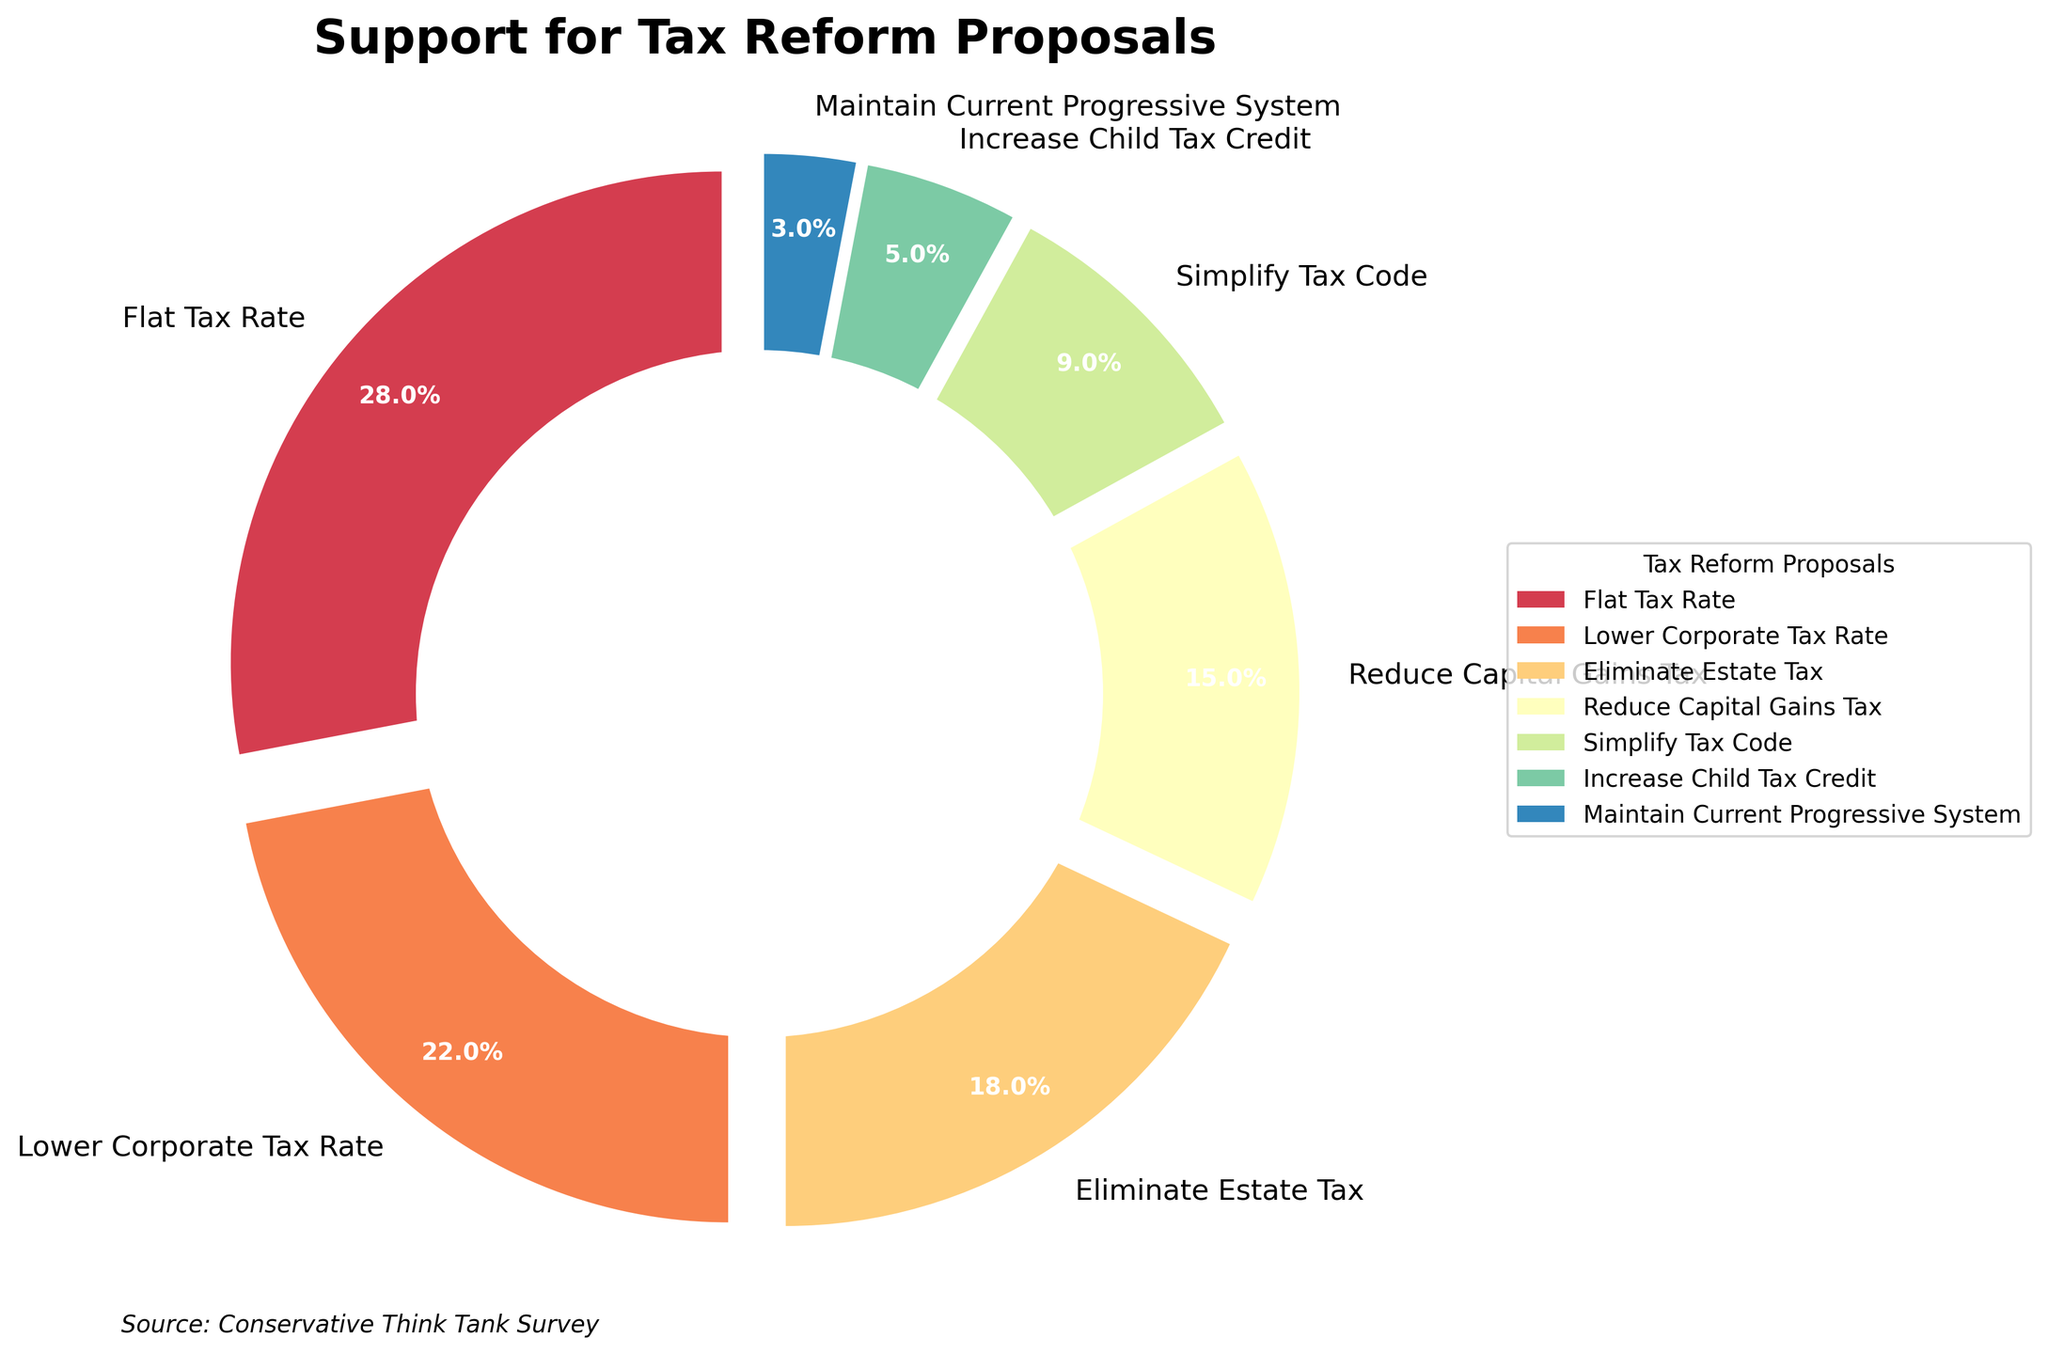What percentage of Americans support the Flat Tax Rate proposal? The Flat Tax Rate segment shows 28% support on the pie chart.
Answer: 28% Which tax reform proposal has the least support? The pie chart indicates that the Current Progressive System has the least support with 3%.
Answer: Current Progressive System By how much does the support for Lower Corporate Tax Rate exceed the support for Reduce Capital Gains Tax? The support for Lower Corporate Tax Rate is 22%, and for Reduce Capital Gains Tax it is 15%. The difference is 22% - 15%.
Answer: 7% What is the combined percentage of Americans supporting the "Eliminate Estate Tax" and "Simplify Tax Code" proposals? The support for Eliminate Estate Tax is 18% and for Simplify Tax Code is 9%. Adding these gives 18% + 9%.
Answer: 27% Which two proposals together account for the largest share of support and what is their combined percentage? The Flat Tax Rate has 28% and Lower Corporate Tax Rate has 22%. Their combined share is 28% + 22%.
Answer: Flat Tax Rate and Lower Corporate Tax Rate, 50% What color represents the support for "Increase Child Tax Credit"? In the pie chart, Increase Child Tax Credit is represented in a particular color among the spectrum displayed.
Answer: (Specify the color seen in the pie chart) If you combine the percentages for "Simplify Tax Code" and "Increase Child Tax Credit," is the total support higher than that for "Eliminate Estate Tax"? Simplify Tax Code has 9% support and Increase Child Tax Credit has 5%. Their combined total is 9% + 5% = 14%, which is less than Eliminate Estate Tax's 18%.
Answer: No Compare the support for "Eliminate Estate Tax" and "Reduce Capital Gains Tax" visually in terms of segment size. Which one is bigger? By observing the size of the segments for Eliminate Estate Tax and Reduce Capital Gains Tax, it is evident that the segment for Eliminate Estate Tax is larger.
Answer: Eliminate Estate Tax How does the support for the "Flat Tax Rate" compare to the overall total support for proposals not generally associated with progressive tax reforms (Lower Corporate Tax Rate, Eliminate Estate Tax, Reduce Capital Gains Tax)? Adding the support percentages for Lower Corporate Tax Rate (22%), Eliminate Estate Tax (18%), and Reduce Capital Gains Tax (15%) gives 55%. Compare this to Flat Tax Rate's 28%.
Answer: Flat Tax Rate is less than the combined other proposals What is the median support percentage among the given proposals? Ordering the support percentages: (3, 5, 9, 15, 18, 22, 28), the median value (middle number) is the fourth number, 15%.
Answer: 15% 